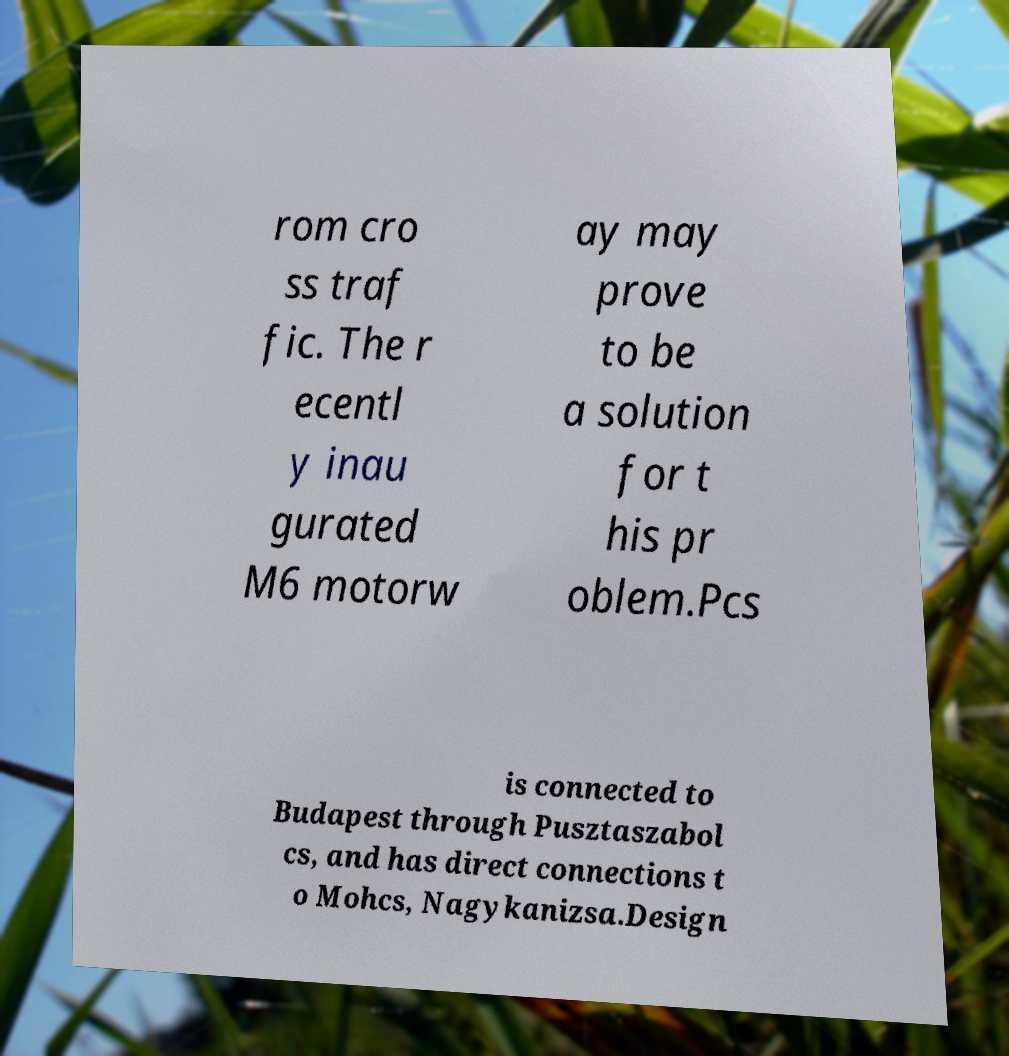What messages or text are displayed in this image? I need them in a readable, typed format. rom cro ss traf fic. The r ecentl y inau gurated M6 motorw ay may prove to be a solution for t his pr oblem.Pcs is connected to Budapest through Pusztaszabol cs, and has direct connections t o Mohcs, Nagykanizsa.Design 